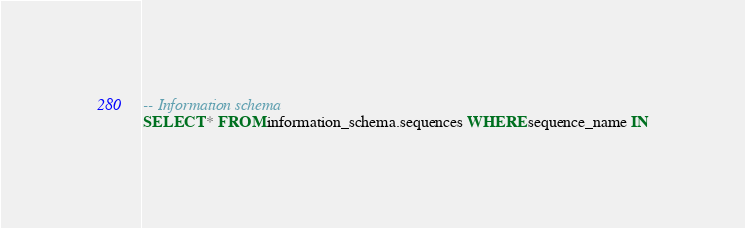<code> <loc_0><loc_0><loc_500><loc_500><_SQL_>
-- Information schema
SELECT * FROM information_schema.sequences WHERE sequence_name IN</code> 